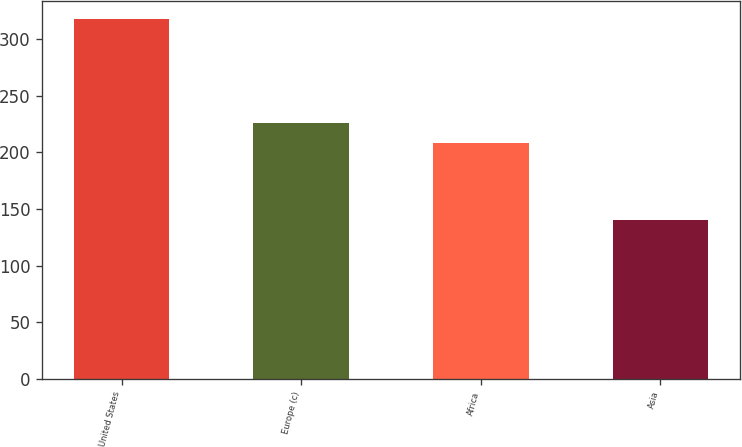<chart> <loc_0><loc_0><loc_500><loc_500><bar_chart><fcel>United States<fcel>Europe (c)<fcel>Africa<fcel>Asia<nl><fcel>318<fcel>225.8<fcel>208<fcel>140<nl></chart> 